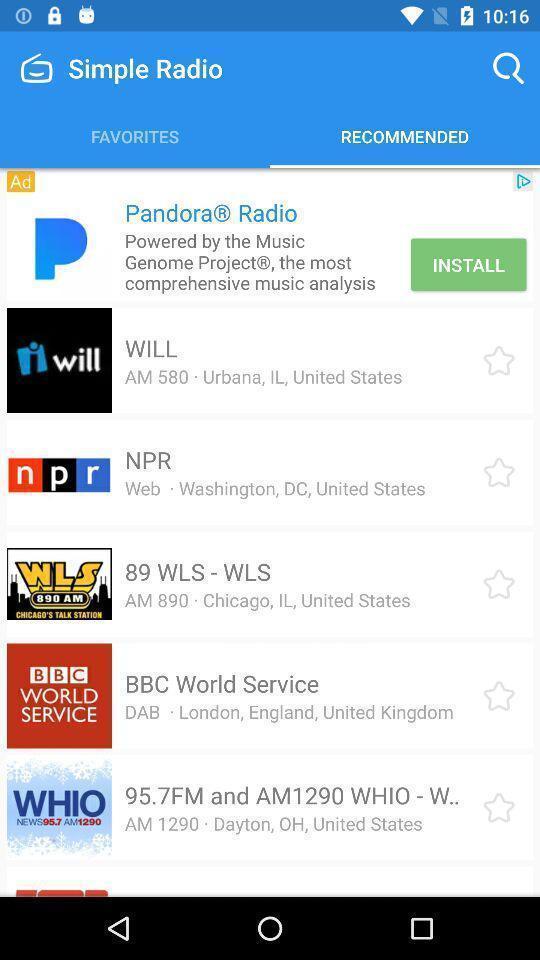Please provide a description for this image. Page showing multiple locations in app. 